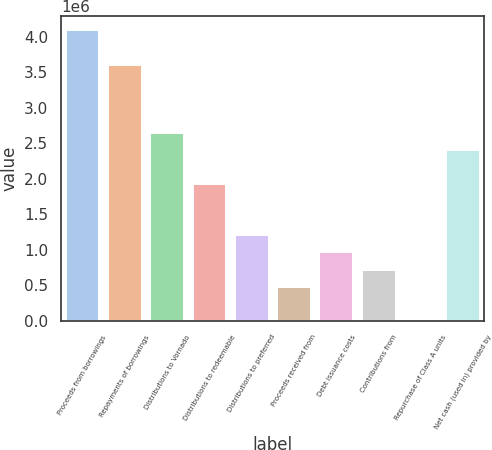Convert chart. <chart><loc_0><loc_0><loc_500><loc_500><bar_chart><fcel>Proceeds from borrowings<fcel>Repayments of borrowings<fcel>Distributions to Vornado<fcel>Distributions to redeemable<fcel>Distributions to preferred<fcel>Proceeds received from<fcel>Debt issuance costs<fcel>Contributions from<fcel>Repurchase of Class A units<fcel>Net cash (used in) provided by<nl><fcel>4.0865e+06<fcel>3.60575e+06<fcel>2.64427e+06<fcel>1.92316e+06<fcel>1.20204e+06<fcel>480928<fcel>961671<fcel>721300<fcel>186<fcel>2.4039e+06<nl></chart> 